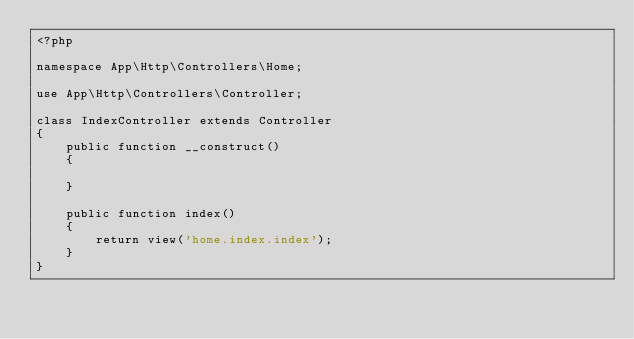<code> <loc_0><loc_0><loc_500><loc_500><_PHP_><?php

namespace App\Http\Controllers\Home;

use App\Http\Controllers\Controller;

class IndexController extends Controller
{
    public function __construct()
    {

    }

    public function index()
    {
        return view('home.index.index');
    }
}</code> 